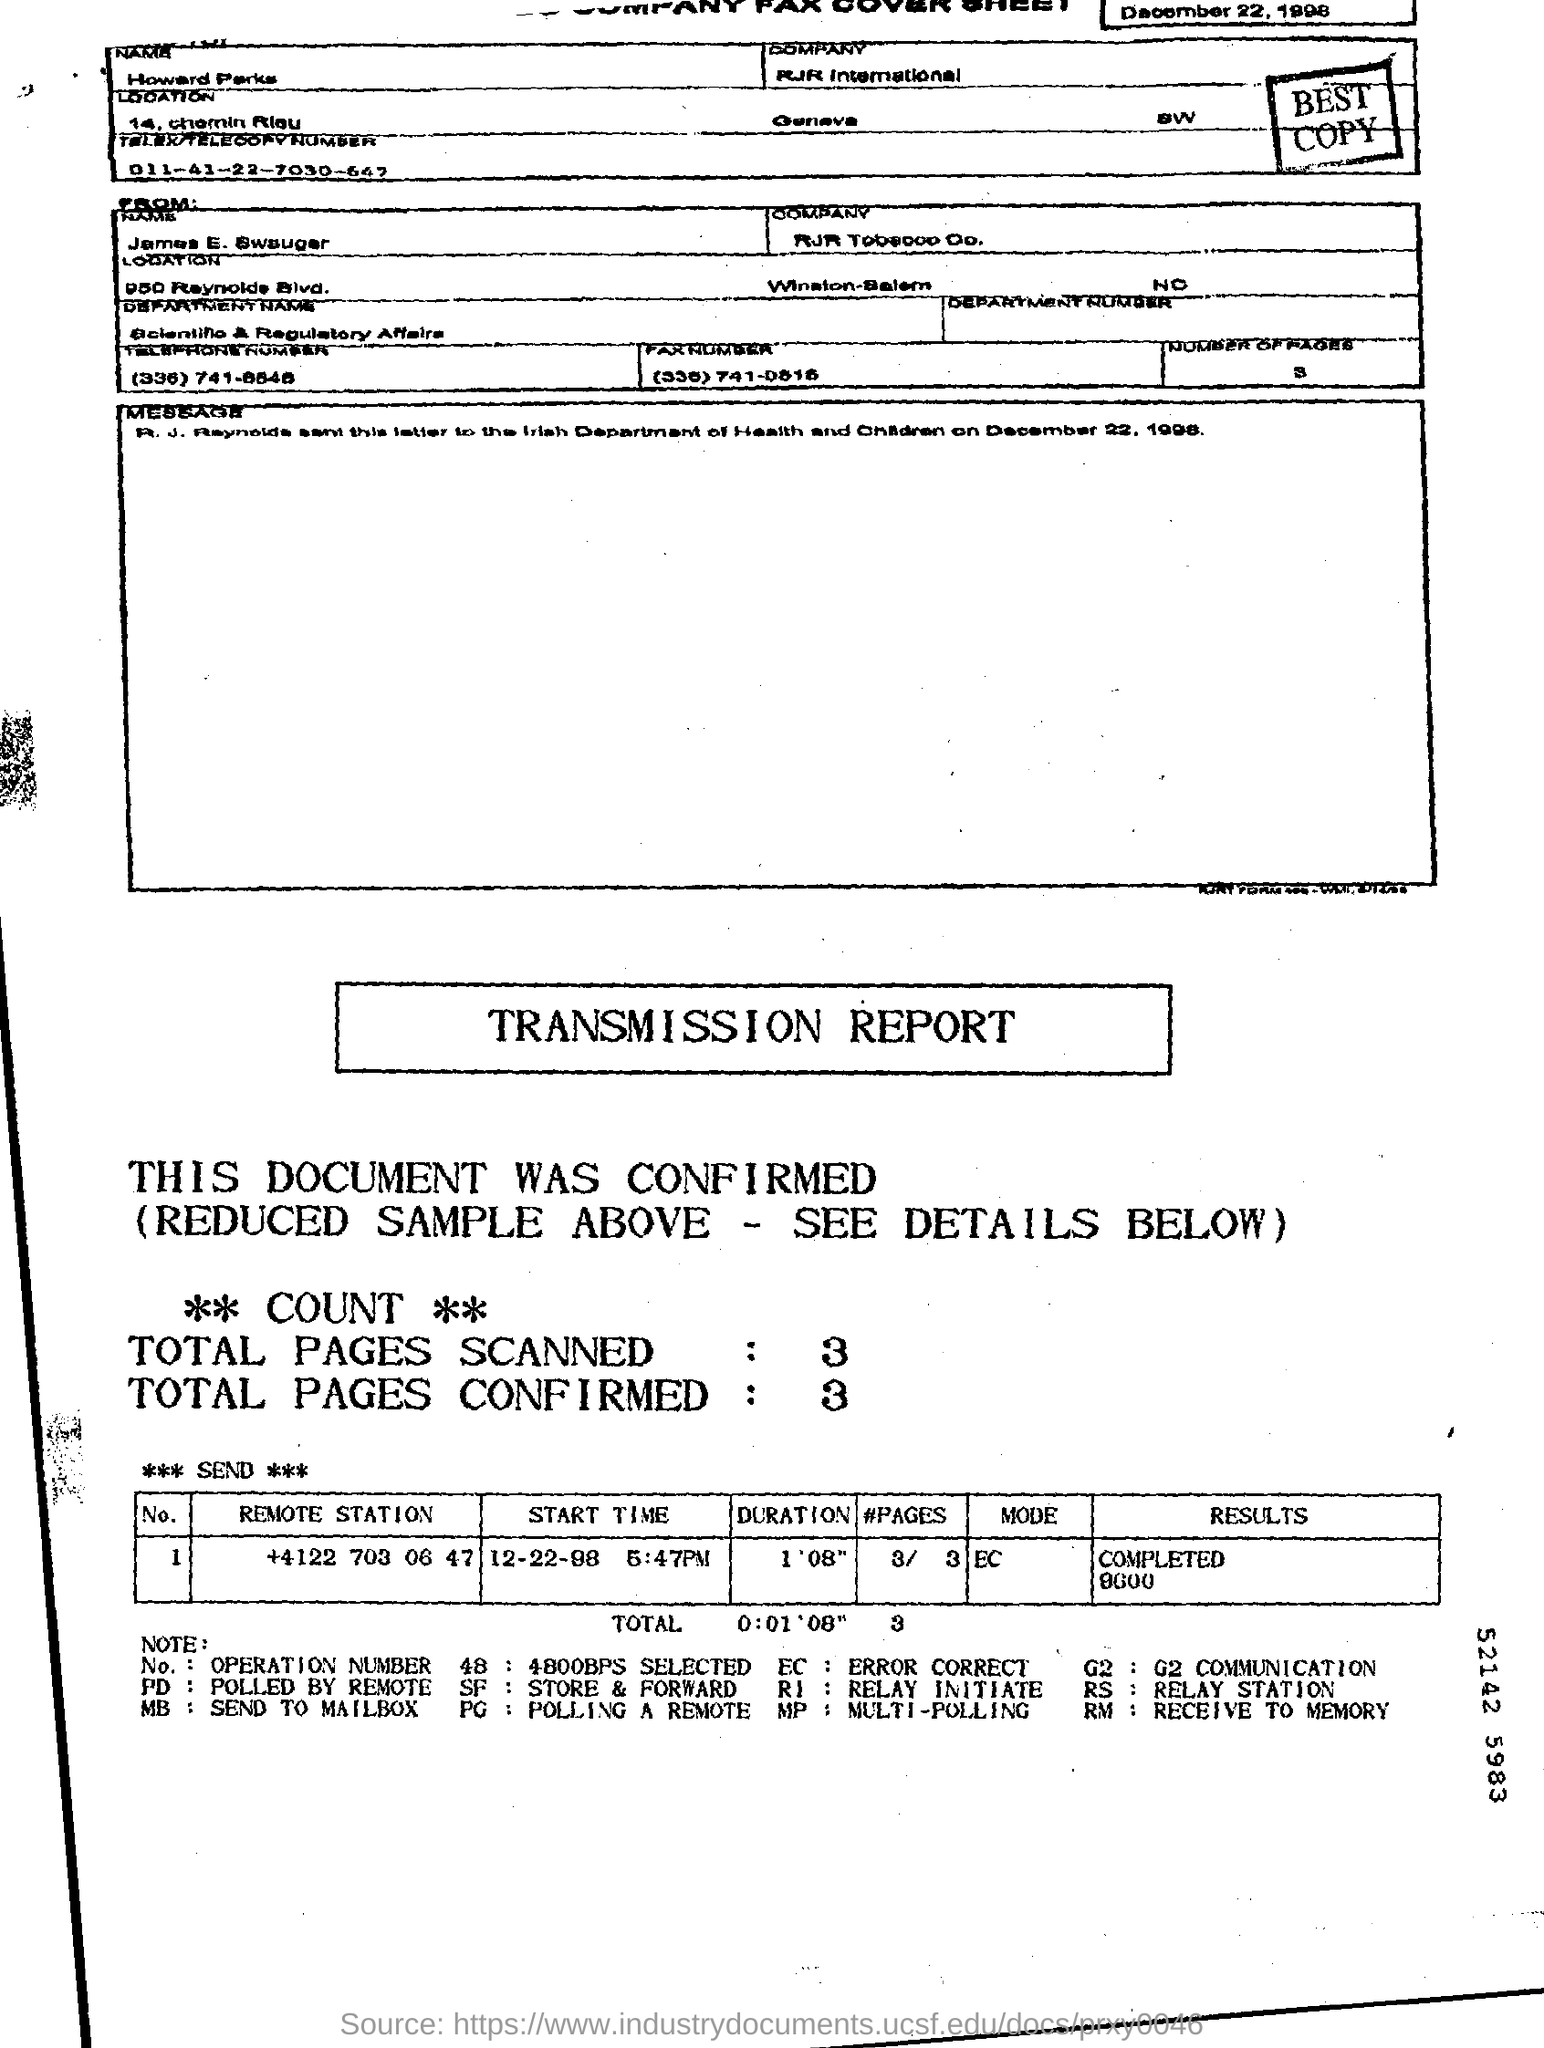List a handful of essential elements in this visual. The code "EC" stands for "ERROR CORRECT." It is used to indicate that a particular message or document has been modified to correct any errors and ensure its accuracy. What is "Send To" company? RJR international. The "Results" for the "Remote Station" with a phone number of +4122 703 06 47 have been completed and show a result of 9600. The date is December 22, 1998. The start time for the remote station with the phone number +4122 703 06 47 is December 22, 1998 at 5:47 PM. 